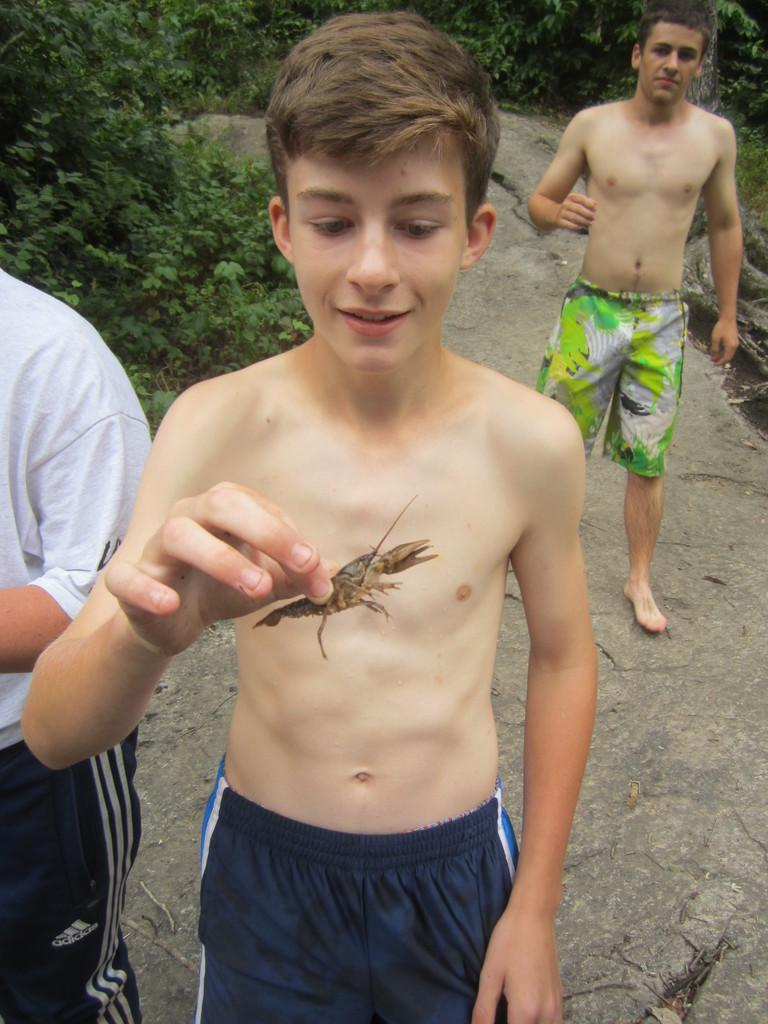How many people are in the image? There are three men in the picture. What is one of the men doing in the image? One person is catching an insect. What type of natural environment is visible in the image? There are trees in the picture. What type of record is being played in the image? There is no record or music player visible in the image. Is there a squirrel present in the image? There is no squirrel visible in the image. 